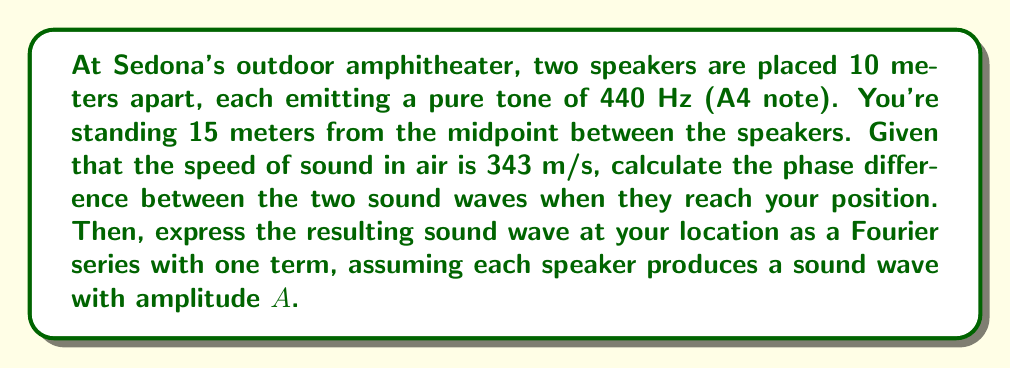Help me with this question. Let's approach this step-by-step:

1) First, we need to calculate the distances from each speaker to your position. Let's call the distance to the left speaker $d_1$ and to the right speaker $d_2$.

   Using the Pythagorean theorem:
   $$d_1 = \sqrt{15^2 + 5^2} = \sqrt{250} \approx 15.81 \text{ m}$$
   $$d_2 = \sqrt{15^2 + 5^2} = \sqrt{250} \approx 15.81 \text{ m}$$

2) The wavelength $\lambda$ of the sound is:
   $$\lambda = \frac{v}{f} = \frac{343 \text{ m/s}}{440 \text{ Hz}} \approx 0.78 \text{ m}$$

3) The phase difference $\Delta \phi$ is given by:
   $$\Delta \phi = \frac{2\pi}{\lambda}(d_2 - d_1) = \frac{2\pi}{0.78}(15.81 - 15.81) = 0$$

4) Since the phase difference is zero, the waves from both speakers arrive in phase at your position.

5) The resulting wave can be expressed as a Fourier series with one term:
   $$y(t) = 2A \cos(2\pi f t)$$

   Where:
   - $2A$ is the amplitude (twice the original amplitude due to constructive interference)
   - $f = 440 \text{ Hz}$ is the frequency
   - $t$ is time

This Fourier series representation assumes perfect constructive interference and neglects any attenuation due to distance.
Answer: The phase difference is 0 radians, and the resulting sound wave at your location can be expressed as the Fourier series:
$$y(t) = 2A \cos(880\pi t)$$
where $A$ is the amplitude of each individual speaker's sound wave. 